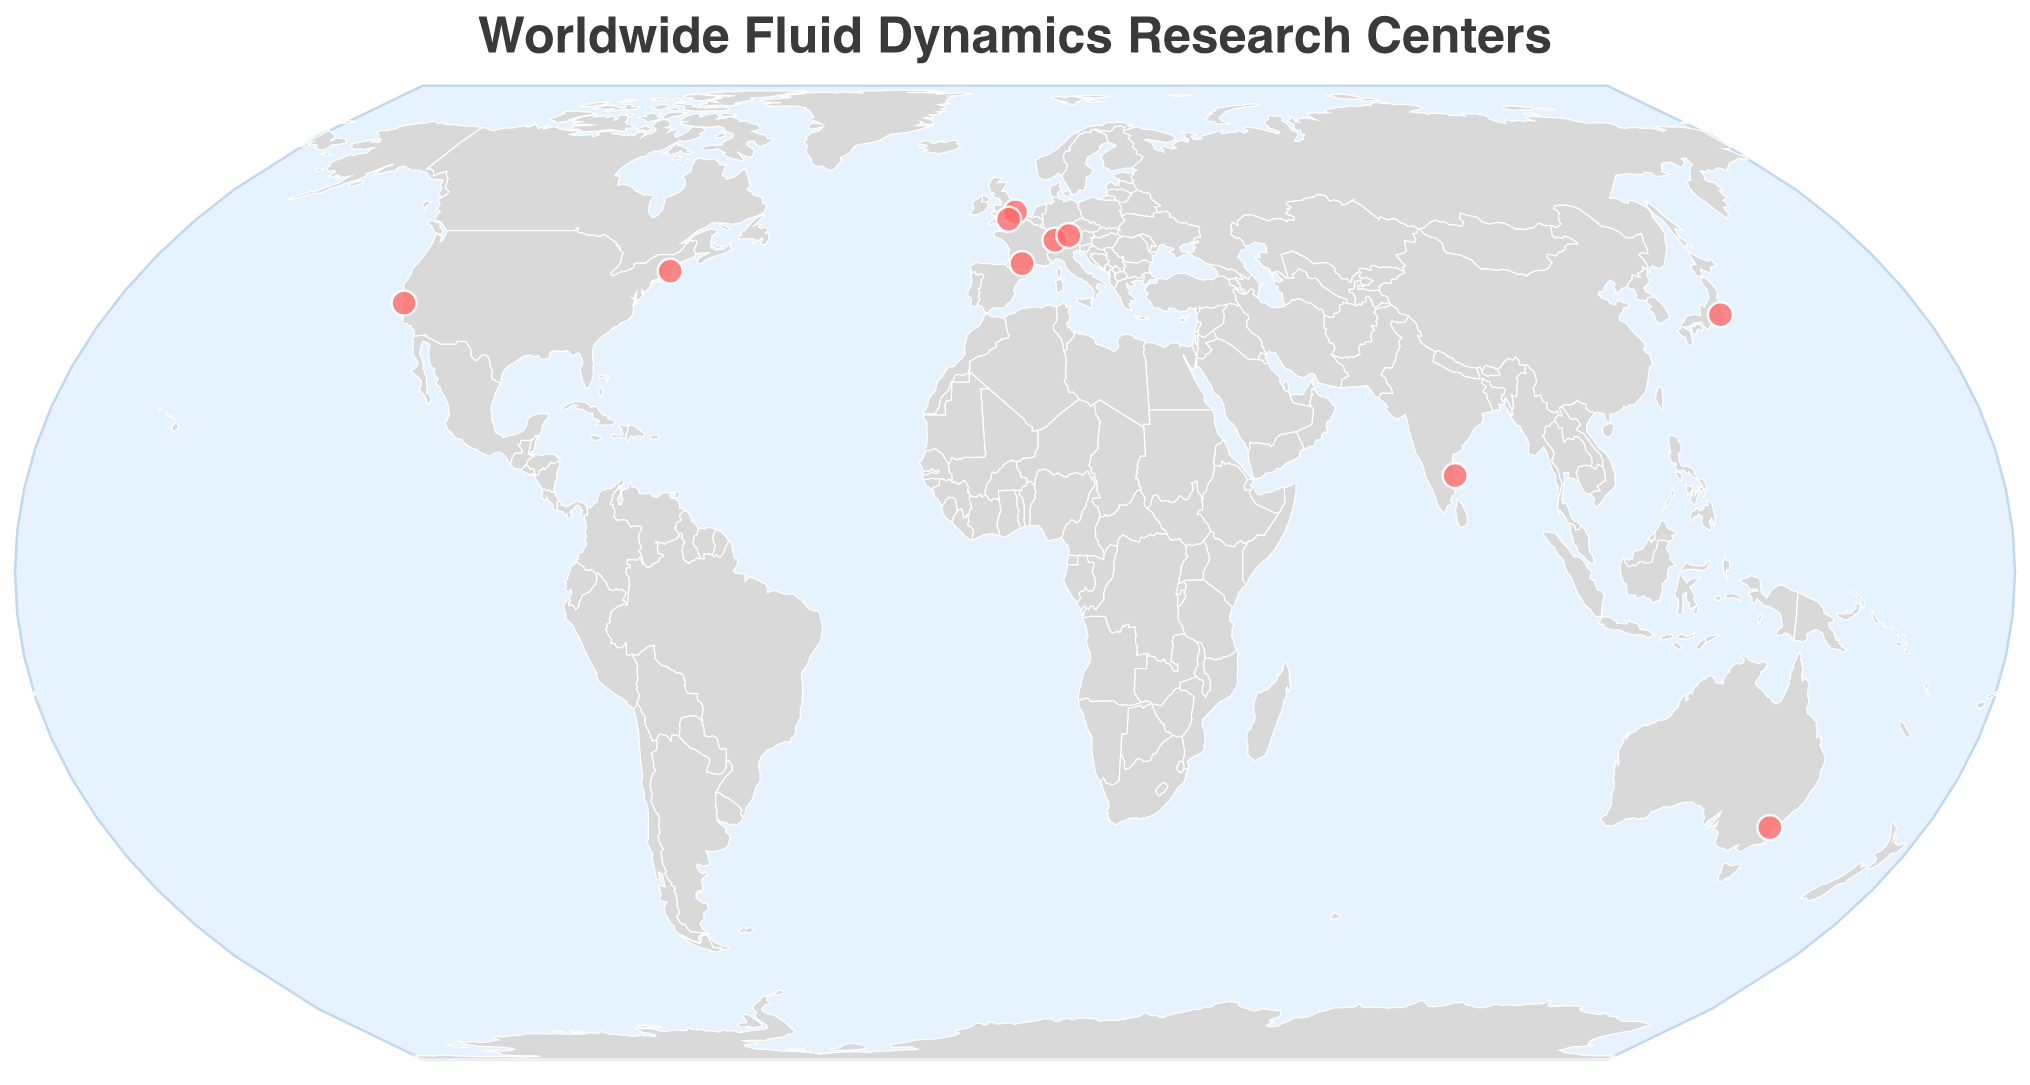Which university specializes in Experimental Fluid Mechanics? The name displayed on the tooltip for the point with specialization "Experimental Fluid Mechanics" is "Indian Institute of Technology Madras Fluid Mechanics Laboratory".
Answer: Indian Institute of Technology Madras How many research centers are located in Europe? By examining the locations on the map, we can count four research centers in Europe: University of Cambridge Fluids Group, ETH Zurich Institute of Fluid Dynamics, CNRS Institut de Mécanique des Fluides de Toulouse, and Technical University of Munich Chair of Aerodynamics and Fluid Mechanics.
Answer: Four Which research centers are located in the United States? The tooltip for the two locations in the United States shows the following names: "Massachusetts Institute of Technology Fluid Dynamics Research Laboratory" and "Stanford University Center for Turbulence Research".
Answer: Massachusetts Institute of Technology Fluid Dynamics Research Laboratory and Stanford University Center for Turbulence Research What is the specialization of the research center at the southernmost point in the map? The southernmost point on the map is marked at the latitude of -35.2809, which is "Australian National University Fluid Dynamics Group", specializing in "Environmental Fluid Dynamics".
Answer: Environmental Fluid Dynamics How many research centers focus on turbulence or turbulence-related topics? Two research centers specialize in turbulence-related topics: "Massachusetts Institute of Technology Fluid Dynamics Research Laboratory" (Turbulence and Multiphase Flows) and "Stanford University Center for Turbulence Research" (Turbulence Modeling and Simulation).
Answer: Two Which research center is closest to the International Date Line? The closest point to the International Date Line is the one with longitude 139.6917. The tooltip shows "Tokyo University of Science Fluid Engineering Laboratory" for this location.
Answer: Tokyo University of Science Fluid Engineering Laboratory Which two continents have exactly one research center each? By examining the locations, we can identify that Australia and Asia each have one research center: "Australian National University Fluid Dynamics Group" and "Tokyo University of Science Fluid Engineering Laboratory".
Answer: Australia and Asia What is the title of the map? The title of the map is "Worldwide Fluid Dynamics Research Centers".
Answer: Worldwide Fluid Dynamics Research Centers Which university's research center is focused on Aerodynamics and Hydrodynamics? The tooltip information for "Aerodynamics and Hydrodynamics" is "CNRS Institut de Mécanique des Fluides de Toulouse".
Answer: CNRS Institut de Mécanique des Fluides de Toulouse How many different specializations are represented in the plot? By examining the tooltip information for each point, we find eight unique specializations: Turbulence and Multiphase Flows, Geophysical Fluid Dynamics, Computational Fluid Dynamics, Microfluidics and Nanofluidics, Aerodynamics and Hydrodynamics, Turbulence Modeling and Simulation, Environmental Fluid Dynamics, and Experimental Fluid Mechanics.
Answer: Eight 